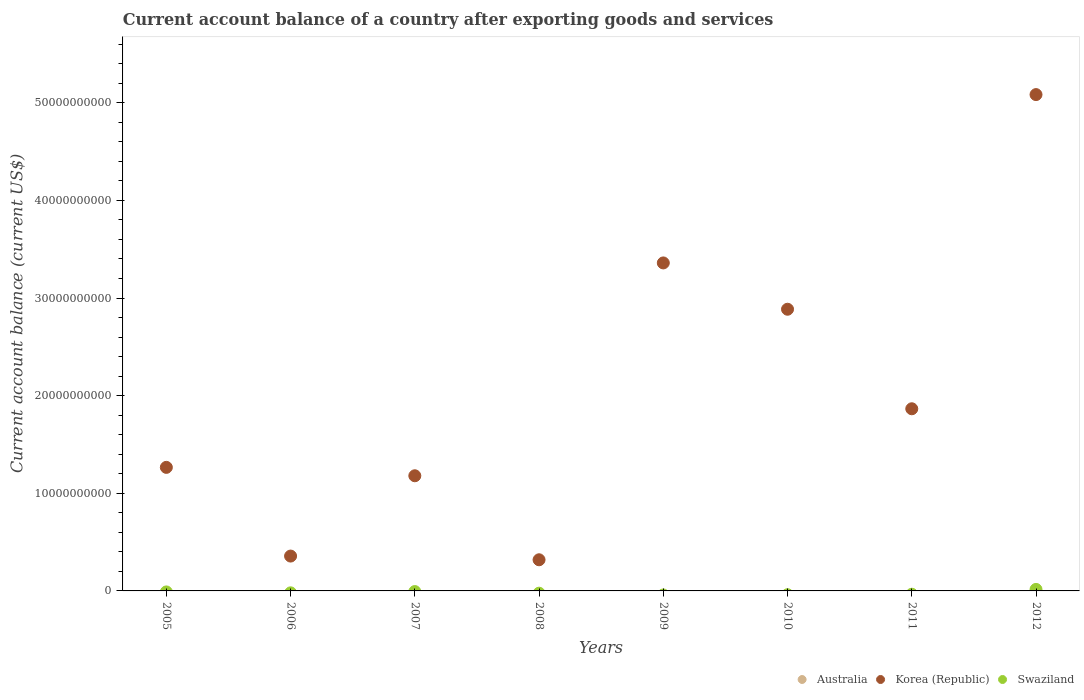Across all years, what is the maximum account balance in Korea (Republic)?
Offer a very short reply. 5.08e+1. What is the total account balance in Korea (Republic) in the graph?
Keep it short and to the point. 1.63e+11. What is the difference between the account balance in Korea (Republic) in 2005 and that in 2011?
Keep it short and to the point. -6.00e+09. What is the difference between the account balance in Australia in 2012 and the account balance in Korea (Republic) in 2007?
Give a very brief answer. -1.18e+1. What is the average account balance in Australia per year?
Your answer should be very brief. 0. What is the difference between the highest and the second highest account balance in Korea (Republic)?
Make the answer very short. 1.72e+1. What is the difference between the highest and the lowest account balance in Korea (Republic)?
Make the answer very short. 4.76e+1. Is the sum of the account balance in Korea (Republic) in 2006 and 2011 greater than the maximum account balance in Swaziland across all years?
Offer a very short reply. Yes. Is it the case that in every year, the sum of the account balance in Australia and account balance in Korea (Republic)  is greater than the account balance in Swaziland?
Offer a terse response. Yes. Is the account balance in Swaziland strictly less than the account balance in Australia over the years?
Offer a very short reply. No. How many dotlines are there?
Make the answer very short. 2. What is the difference between two consecutive major ticks on the Y-axis?
Provide a succinct answer. 1.00e+1. Where does the legend appear in the graph?
Keep it short and to the point. Bottom right. What is the title of the graph?
Offer a terse response. Current account balance of a country after exporting goods and services. What is the label or title of the Y-axis?
Provide a short and direct response. Current account balance (current US$). What is the Current account balance (current US$) of Korea (Republic) in 2005?
Give a very brief answer. 1.27e+1. What is the Current account balance (current US$) of Swaziland in 2005?
Provide a succinct answer. 0. What is the Current account balance (current US$) in Australia in 2006?
Ensure brevity in your answer.  0. What is the Current account balance (current US$) of Korea (Republic) in 2006?
Your response must be concise. 3.57e+09. What is the Current account balance (current US$) in Korea (Republic) in 2007?
Your response must be concise. 1.18e+1. What is the Current account balance (current US$) in Australia in 2008?
Your answer should be compact. 0. What is the Current account balance (current US$) in Korea (Republic) in 2008?
Provide a short and direct response. 3.19e+09. What is the Current account balance (current US$) of Swaziland in 2008?
Your answer should be very brief. 0. What is the Current account balance (current US$) in Australia in 2009?
Offer a terse response. 0. What is the Current account balance (current US$) in Korea (Republic) in 2009?
Your answer should be very brief. 3.36e+1. What is the Current account balance (current US$) in Swaziland in 2009?
Your answer should be very brief. 0. What is the Current account balance (current US$) in Korea (Republic) in 2010?
Give a very brief answer. 2.89e+1. What is the Current account balance (current US$) in Australia in 2011?
Your answer should be very brief. 0. What is the Current account balance (current US$) in Korea (Republic) in 2011?
Provide a short and direct response. 1.87e+1. What is the Current account balance (current US$) of Swaziland in 2011?
Provide a succinct answer. 0. What is the Current account balance (current US$) in Australia in 2012?
Your answer should be very brief. 0. What is the Current account balance (current US$) in Korea (Republic) in 2012?
Provide a succinct answer. 5.08e+1. What is the Current account balance (current US$) of Swaziland in 2012?
Your answer should be very brief. 1.55e+08. Across all years, what is the maximum Current account balance (current US$) in Korea (Republic)?
Keep it short and to the point. 5.08e+1. Across all years, what is the maximum Current account balance (current US$) in Swaziland?
Offer a very short reply. 1.55e+08. Across all years, what is the minimum Current account balance (current US$) in Korea (Republic)?
Offer a terse response. 3.19e+09. Across all years, what is the minimum Current account balance (current US$) in Swaziland?
Your answer should be compact. 0. What is the total Current account balance (current US$) in Australia in the graph?
Your answer should be very brief. 0. What is the total Current account balance (current US$) of Korea (Republic) in the graph?
Your answer should be very brief. 1.63e+11. What is the total Current account balance (current US$) in Swaziland in the graph?
Keep it short and to the point. 1.55e+08. What is the difference between the Current account balance (current US$) in Korea (Republic) in 2005 and that in 2006?
Keep it short and to the point. 9.09e+09. What is the difference between the Current account balance (current US$) of Korea (Republic) in 2005 and that in 2007?
Provide a succinct answer. 8.60e+08. What is the difference between the Current account balance (current US$) in Korea (Republic) in 2005 and that in 2008?
Your answer should be very brief. 9.47e+09. What is the difference between the Current account balance (current US$) in Korea (Republic) in 2005 and that in 2009?
Your answer should be compact. -2.09e+1. What is the difference between the Current account balance (current US$) in Korea (Republic) in 2005 and that in 2010?
Keep it short and to the point. -1.62e+1. What is the difference between the Current account balance (current US$) of Korea (Republic) in 2005 and that in 2011?
Your answer should be compact. -6.00e+09. What is the difference between the Current account balance (current US$) in Korea (Republic) in 2005 and that in 2012?
Your answer should be very brief. -3.82e+1. What is the difference between the Current account balance (current US$) in Korea (Republic) in 2006 and that in 2007?
Offer a very short reply. -8.23e+09. What is the difference between the Current account balance (current US$) of Korea (Republic) in 2006 and that in 2008?
Offer a very short reply. 3.80e+08. What is the difference between the Current account balance (current US$) of Korea (Republic) in 2006 and that in 2009?
Make the answer very short. -3.00e+1. What is the difference between the Current account balance (current US$) of Korea (Republic) in 2006 and that in 2010?
Offer a terse response. -2.53e+1. What is the difference between the Current account balance (current US$) in Korea (Republic) in 2006 and that in 2011?
Provide a short and direct response. -1.51e+1. What is the difference between the Current account balance (current US$) in Korea (Republic) in 2006 and that in 2012?
Offer a terse response. -4.73e+1. What is the difference between the Current account balance (current US$) of Korea (Republic) in 2007 and that in 2008?
Your answer should be compact. 8.60e+09. What is the difference between the Current account balance (current US$) in Korea (Republic) in 2007 and that in 2009?
Your answer should be compact. -2.18e+1. What is the difference between the Current account balance (current US$) in Korea (Republic) in 2007 and that in 2010?
Give a very brief answer. -1.71e+1. What is the difference between the Current account balance (current US$) in Korea (Republic) in 2007 and that in 2011?
Your response must be concise. -6.86e+09. What is the difference between the Current account balance (current US$) in Korea (Republic) in 2007 and that in 2012?
Provide a short and direct response. -3.90e+1. What is the difference between the Current account balance (current US$) of Korea (Republic) in 2008 and that in 2009?
Keep it short and to the point. -3.04e+1. What is the difference between the Current account balance (current US$) in Korea (Republic) in 2008 and that in 2010?
Keep it short and to the point. -2.57e+1. What is the difference between the Current account balance (current US$) in Korea (Republic) in 2008 and that in 2011?
Give a very brief answer. -1.55e+1. What is the difference between the Current account balance (current US$) in Korea (Republic) in 2008 and that in 2012?
Provide a succinct answer. -4.76e+1. What is the difference between the Current account balance (current US$) in Korea (Republic) in 2009 and that in 2010?
Make the answer very short. 4.74e+09. What is the difference between the Current account balance (current US$) of Korea (Republic) in 2009 and that in 2011?
Your answer should be compact. 1.49e+1. What is the difference between the Current account balance (current US$) in Korea (Republic) in 2009 and that in 2012?
Your answer should be compact. -1.72e+1. What is the difference between the Current account balance (current US$) of Korea (Republic) in 2010 and that in 2011?
Provide a succinct answer. 1.02e+1. What is the difference between the Current account balance (current US$) in Korea (Republic) in 2010 and that in 2012?
Offer a very short reply. -2.20e+1. What is the difference between the Current account balance (current US$) of Korea (Republic) in 2011 and that in 2012?
Your answer should be compact. -3.22e+1. What is the difference between the Current account balance (current US$) in Korea (Republic) in 2005 and the Current account balance (current US$) in Swaziland in 2012?
Provide a short and direct response. 1.25e+1. What is the difference between the Current account balance (current US$) of Korea (Republic) in 2006 and the Current account balance (current US$) of Swaziland in 2012?
Offer a very short reply. 3.41e+09. What is the difference between the Current account balance (current US$) in Korea (Republic) in 2007 and the Current account balance (current US$) in Swaziland in 2012?
Give a very brief answer. 1.16e+1. What is the difference between the Current account balance (current US$) of Korea (Republic) in 2008 and the Current account balance (current US$) of Swaziland in 2012?
Offer a very short reply. 3.03e+09. What is the difference between the Current account balance (current US$) of Korea (Republic) in 2009 and the Current account balance (current US$) of Swaziland in 2012?
Your response must be concise. 3.34e+1. What is the difference between the Current account balance (current US$) in Korea (Republic) in 2010 and the Current account balance (current US$) in Swaziland in 2012?
Offer a terse response. 2.87e+1. What is the difference between the Current account balance (current US$) of Korea (Republic) in 2011 and the Current account balance (current US$) of Swaziland in 2012?
Provide a short and direct response. 1.85e+1. What is the average Current account balance (current US$) of Korea (Republic) per year?
Your answer should be compact. 2.04e+1. What is the average Current account balance (current US$) in Swaziland per year?
Ensure brevity in your answer.  1.93e+07. In the year 2012, what is the difference between the Current account balance (current US$) of Korea (Republic) and Current account balance (current US$) of Swaziland?
Ensure brevity in your answer.  5.07e+1. What is the ratio of the Current account balance (current US$) of Korea (Republic) in 2005 to that in 2006?
Offer a very short reply. 3.55. What is the ratio of the Current account balance (current US$) of Korea (Republic) in 2005 to that in 2007?
Ensure brevity in your answer.  1.07. What is the ratio of the Current account balance (current US$) of Korea (Republic) in 2005 to that in 2008?
Provide a succinct answer. 3.97. What is the ratio of the Current account balance (current US$) in Korea (Republic) in 2005 to that in 2009?
Provide a short and direct response. 0.38. What is the ratio of the Current account balance (current US$) in Korea (Republic) in 2005 to that in 2010?
Provide a short and direct response. 0.44. What is the ratio of the Current account balance (current US$) of Korea (Republic) in 2005 to that in 2011?
Provide a succinct answer. 0.68. What is the ratio of the Current account balance (current US$) of Korea (Republic) in 2005 to that in 2012?
Your answer should be compact. 0.25. What is the ratio of the Current account balance (current US$) of Korea (Republic) in 2006 to that in 2007?
Provide a succinct answer. 0.3. What is the ratio of the Current account balance (current US$) in Korea (Republic) in 2006 to that in 2008?
Provide a short and direct response. 1.12. What is the ratio of the Current account balance (current US$) in Korea (Republic) in 2006 to that in 2009?
Offer a very short reply. 0.11. What is the ratio of the Current account balance (current US$) in Korea (Republic) in 2006 to that in 2010?
Your answer should be very brief. 0.12. What is the ratio of the Current account balance (current US$) in Korea (Republic) in 2006 to that in 2011?
Offer a very short reply. 0.19. What is the ratio of the Current account balance (current US$) in Korea (Republic) in 2006 to that in 2012?
Your answer should be very brief. 0.07. What is the ratio of the Current account balance (current US$) in Korea (Republic) in 2007 to that in 2008?
Your answer should be compact. 3.7. What is the ratio of the Current account balance (current US$) of Korea (Republic) in 2007 to that in 2009?
Make the answer very short. 0.35. What is the ratio of the Current account balance (current US$) in Korea (Republic) in 2007 to that in 2010?
Ensure brevity in your answer.  0.41. What is the ratio of the Current account balance (current US$) of Korea (Republic) in 2007 to that in 2011?
Make the answer very short. 0.63. What is the ratio of the Current account balance (current US$) in Korea (Republic) in 2007 to that in 2012?
Your answer should be very brief. 0.23. What is the ratio of the Current account balance (current US$) in Korea (Republic) in 2008 to that in 2009?
Your answer should be compact. 0.1. What is the ratio of the Current account balance (current US$) of Korea (Republic) in 2008 to that in 2010?
Give a very brief answer. 0.11. What is the ratio of the Current account balance (current US$) of Korea (Republic) in 2008 to that in 2011?
Give a very brief answer. 0.17. What is the ratio of the Current account balance (current US$) of Korea (Republic) in 2008 to that in 2012?
Provide a short and direct response. 0.06. What is the ratio of the Current account balance (current US$) of Korea (Republic) in 2009 to that in 2010?
Offer a very short reply. 1.16. What is the ratio of the Current account balance (current US$) in Korea (Republic) in 2009 to that in 2011?
Make the answer very short. 1.8. What is the ratio of the Current account balance (current US$) of Korea (Republic) in 2009 to that in 2012?
Offer a terse response. 0.66. What is the ratio of the Current account balance (current US$) in Korea (Republic) in 2010 to that in 2011?
Make the answer very short. 1.55. What is the ratio of the Current account balance (current US$) in Korea (Republic) in 2010 to that in 2012?
Your answer should be compact. 0.57. What is the ratio of the Current account balance (current US$) in Korea (Republic) in 2011 to that in 2012?
Make the answer very short. 0.37. What is the difference between the highest and the second highest Current account balance (current US$) in Korea (Republic)?
Offer a very short reply. 1.72e+1. What is the difference between the highest and the lowest Current account balance (current US$) in Korea (Republic)?
Your response must be concise. 4.76e+1. What is the difference between the highest and the lowest Current account balance (current US$) of Swaziland?
Give a very brief answer. 1.55e+08. 